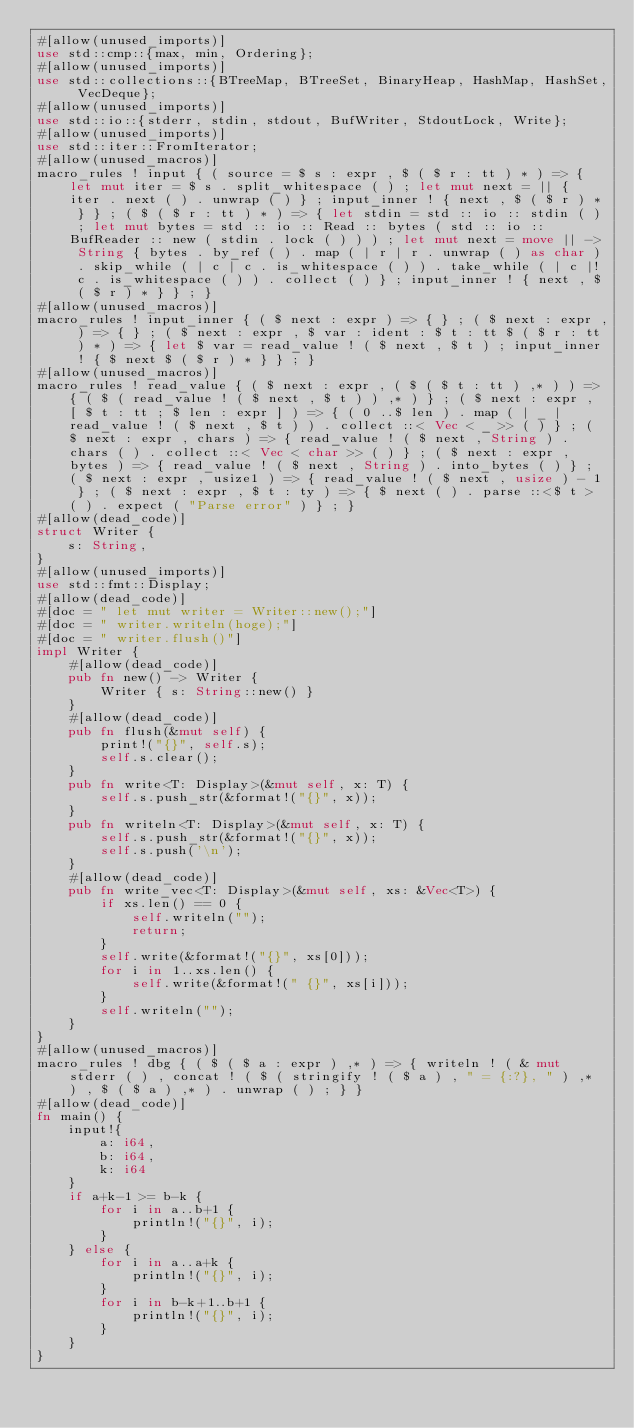<code> <loc_0><loc_0><loc_500><loc_500><_Rust_>#[allow(unused_imports)]
use std::cmp::{max, min, Ordering};
#[allow(unused_imports)]
use std::collections::{BTreeMap, BTreeSet, BinaryHeap, HashMap, HashSet, VecDeque};
#[allow(unused_imports)]
use std::io::{stderr, stdin, stdout, BufWriter, StdoutLock, Write};
#[allow(unused_imports)]
use std::iter::FromIterator;
#[allow(unused_macros)]
macro_rules ! input { ( source = $ s : expr , $ ( $ r : tt ) * ) => { let mut iter = $ s . split_whitespace ( ) ; let mut next = || { iter . next ( ) . unwrap ( ) } ; input_inner ! { next , $ ( $ r ) * } } ; ( $ ( $ r : tt ) * ) => { let stdin = std :: io :: stdin ( ) ; let mut bytes = std :: io :: Read :: bytes ( std :: io :: BufReader :: new ( stdin . lock ( ) ) ) ; let mut next = move || -> String { bytes . by_ref ( ) . map ( | r | r . unwrap ( ) as char ) . skip_while ( | c | c . is_whitespace ( ) ) . take_while ( | c |! c . is_whitespace ( ) ) . collect ( ) } ; input_inner ! { next , $ ( $ r ) * } } ; }
#[allow(unused_macros)]
macro_rules ! input_inner { ( $ next : expr ) => { } ; ( $ next : expr , ) => { } ; ( $ next : expr , $ var : ident : $ t : tt $ ( $ r : tt ) * ) => { let $ var = read_value ! ( $ next , $ t ) ; input_inner ! { $ next $ ( $ r ) * } } ; }
#[allow(unused_macros)]
macro_rules ! read_value { ( $ next : expr , ( $ ( $ t : tt ) ,* ) ) => { ( $ ( read_value ! ( $ next , $ t ) ) ,* ) } ; ( $ next : expr , [ $ t : tt ; $ len : expr ] ) => { ( 0 ..$ len ) . map ( | _ | read_value ! ( $ next , $ t ) ) . collect ::< Vec < _ >> ( ) } ; ( $ next : expr , chars ) => { read_value ! ( $ next , String ) . chars ( ) . collect ::< Vec < char >> ( ) } ; ( $ next : expr , bytes ) => { read_value ! ( $ next , String ) . into_bytes ( ) } ; ( $ next : expr , usize1 ) => { read_value ! ( $ next , usize ) - 1 } ; ( $ next : expr , $ t : ty ) => { $ next ( ) . parse ::<$ t > ( ) . expect ( "Parse error" ) } ; }
#[allow(dead_code)]
struct Writer {
    s: String,
}
#[allow(unused_imports)]
use std::fmt::Display;
#[allow(dead_code)]
#[doc = " let mut writer = Writer::new();"]
#[doc = " writer.writeln(hoge);"]
#[doc = " writer.flush()"]
impl Writer {
    #[allow(dead_code)]
    pub fn new() -> Writer {
        Writer { s: String::new() }
    }
    #[allow(dead_code)]
    pub fn flush(&mut self) {
        print!("{}", self.s);
        self.s.clear();
    }
    pub fn write<T: Display>(&mut self, x: T) {
        self.s.push_str(&format!("{}", x));
    }
    pub fn writeln<T: Display>(&mut self, x: T) {
        self.s.push_str(&format!("{}", x));
        self.s.push('\n');
    }
    #[allow(dead_code)]
    pub fn write_vec<T: Display>(&mut self, xs: &Vec<T>) {
        if xs.len() == 0 {
            self.writeln("");
            return;
        }
        self.write(&format!("{}", xs[0]));
        for i in 1..xs.len() {
            self.write(&format!(" {}", xs[i]));
        }
        self.writeln("");
    }
}
#[allow(unused_macros)]
macro_rules ! dbg { ( $ ( $ a : expr ) ,* ) => { writeln ! ( & mut stderr ( ) , concat ! ( $ ( stringify ! ( $ a ) , " = {:?}, " ) ,* ) , $ ( $ a ) ,* ) . unwrap ( ) ; } }
#[allow(dead_code)]
fn main() {
    input!{
        a: i64,
        b: i64,
        k: i64
    }
    if a+k-1 >= b-k {
        for i in a..b+1 {
            println!("{}", i);
        }
    } else {
        for i in a..a+k {
            println!("{}", i);
        }
        for i in b-k+1..b+1 {
            println!("{}", i);
        }
    }
}</code> 